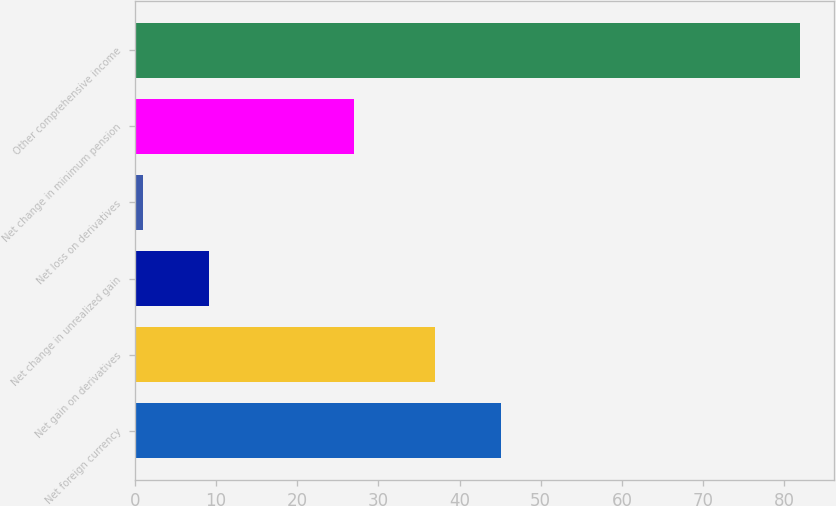<chart> <loc_0><loc_0><loc_500><loc_500><bar_chart><fcel>Net foreign currency<fcel>Net gain on derivatives<fcel>Net change in unrealized gain<fcel>Net loss on derivatives<fcel>Net change in minimum pension<fcel>Other comprehensive income<nl><fcel>45.1<fcel>37<fcel>9.1<fcel>1<fcel>27<fcel>82<nl></chart> 